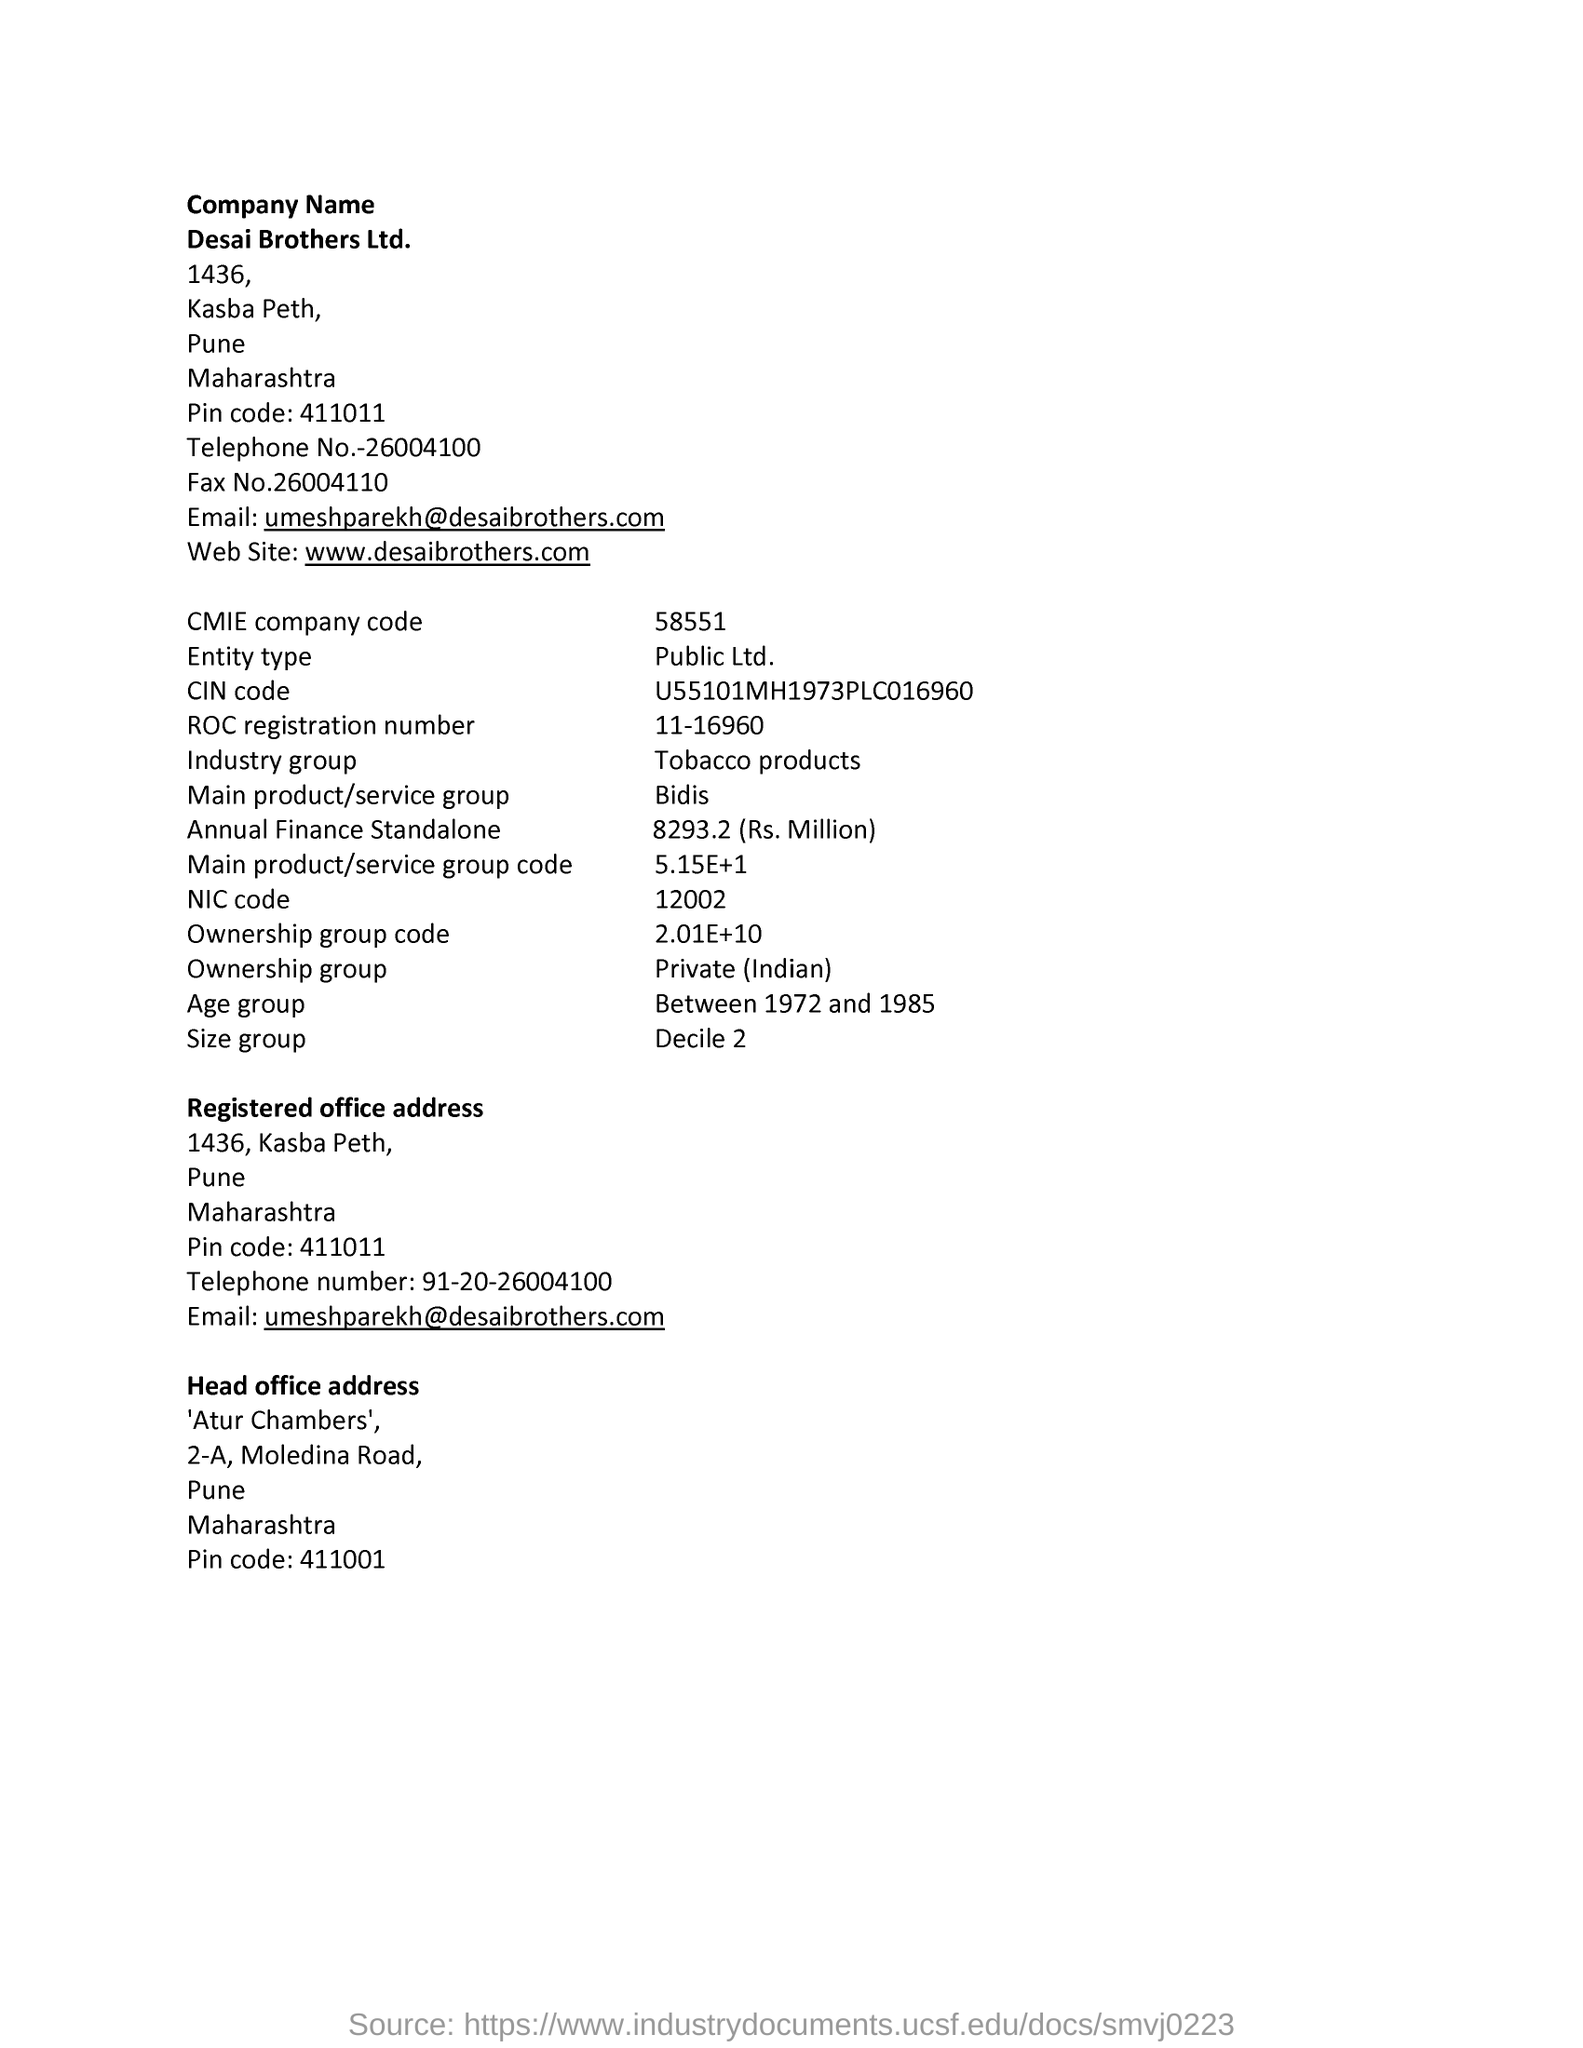What's the official website of the company?
Keep it short and to the point. Www.desaibrothers.com. Which industry group does the company fall under?
Your answer should be very brief. Tobacco products. What is the Age group of the company?
Your answer should be compact. Between 1972 and 1985. What is the name of Main product/service group the company related?
Make the answer very short. Bidis. 